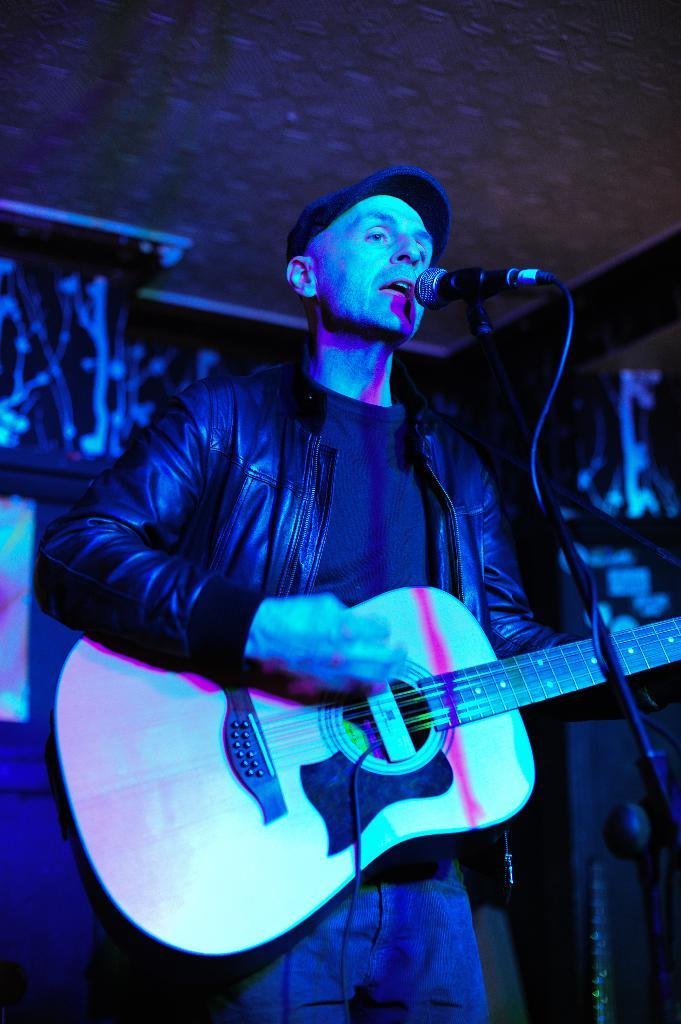What is the person in the image doing? The person is playing a guitar and singing. What object is in front of the person? There is a microphone with a stand in front of the person. What can be seen in the background of the image? There is a wall in the background of the image. What type of print can be seen on the person's skirt in the image? There is no skirt present in the image, and therefore no print can be observed. 